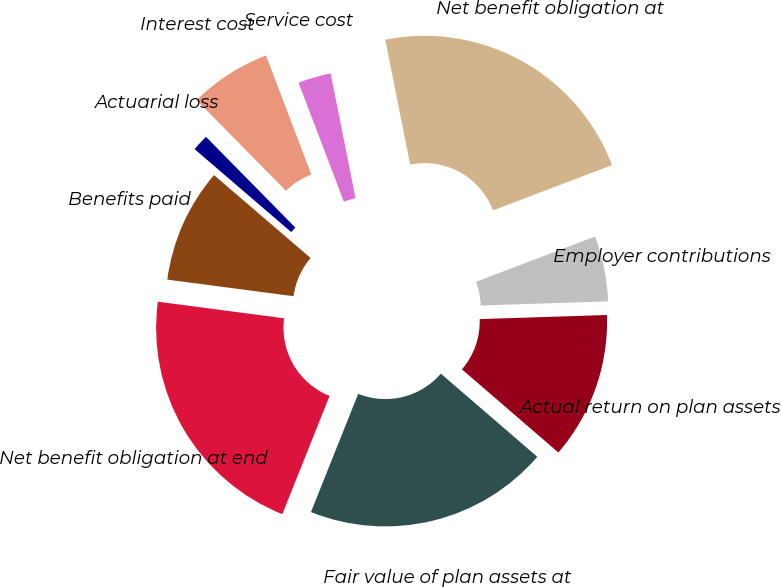<chart> <loc_0><loc_0><loc_500><loc_500><pie_chart><fcel>Net benefit obligation at<fcel>Service cost<fcel>Interest cost<fcel>Actuarial loss<fcel>Benefits paid<fcel>Net benefit obligation at end<fcel>Fair value of plan assets at<fcel>Actual return on plan assets<fcel>Employer contributions<nl><fcel>22.35%<fcel>2.65%<fcel>6.59%<fcel>1.33%<fcel>9.21%<fcel>21.03%<fcel>19.72%<fcel>11.84%<fcel>5.27%<nl></chart> 